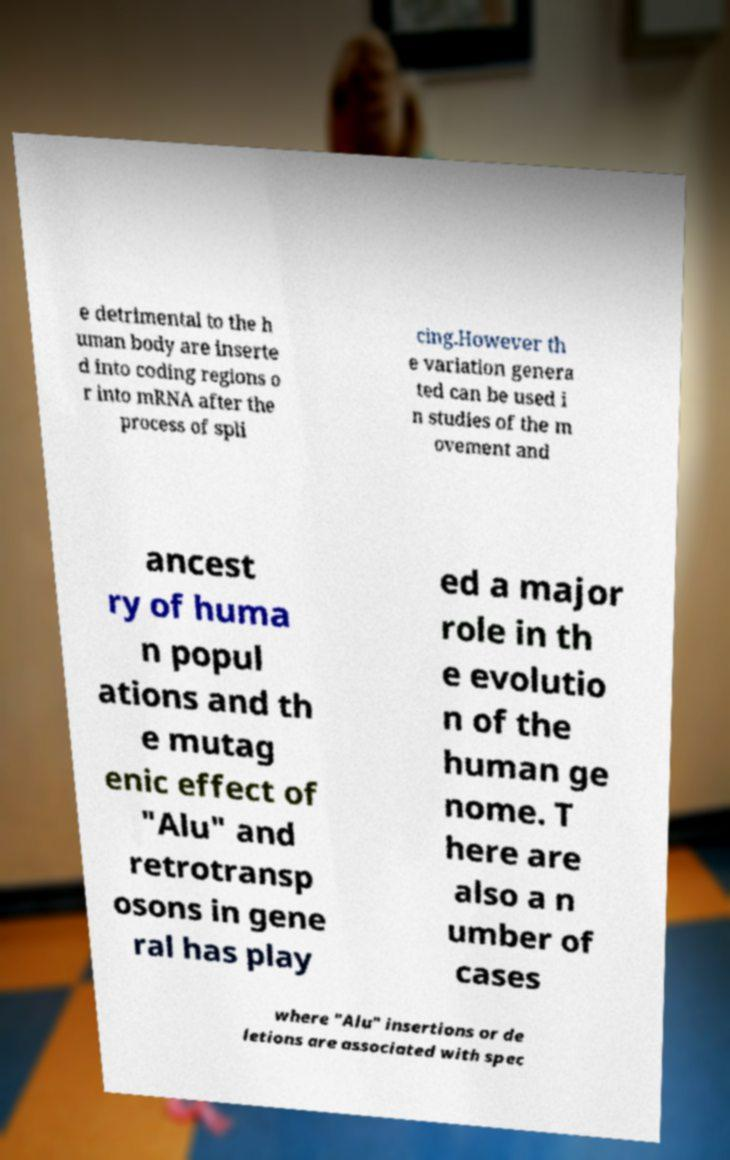There's text embedded in this image that I need extracted. Can you transcribe it verbatim? e detrimental to the h uman body are inserte d into coding regions o r into mRNA after the process of spli cing.However th e variation genera ted can be used i n studies of the m ovement and ancest ry of huma n popul ations and th e mutag enic effect of "Alu" and retrotransp osons in gene ral has play ed a major role in th e evolutio n of the human ge nome. T here are also a n umber of cases where "Alu" insertions or de letions are associated with spec 